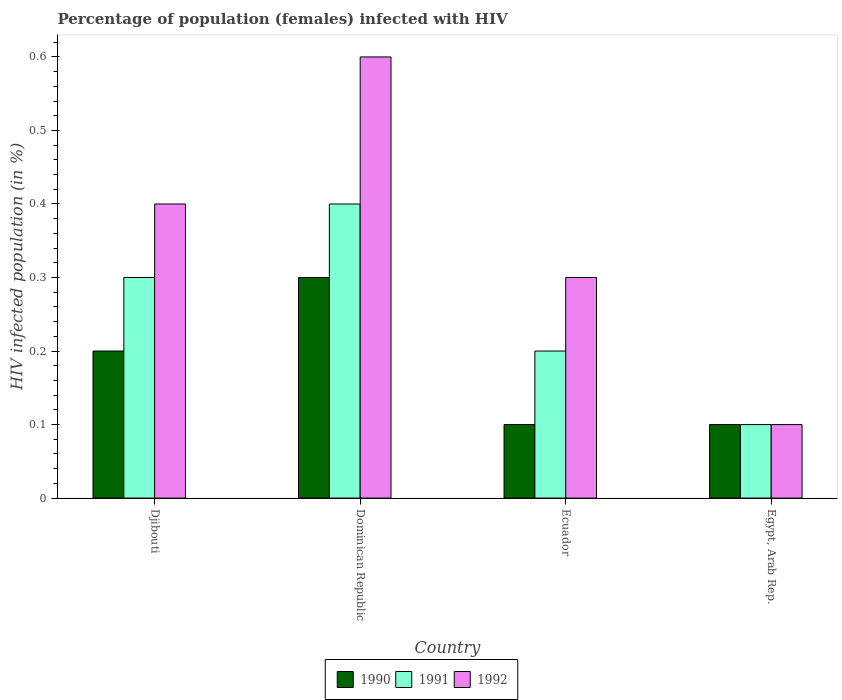How many groups of bars are there?
Offer a terse response. 4. Are the number of bars on each tick of the X-axis equal?
Keep it short and to the point. Yes. How many bars are there on the 4th tick from the left?
Ensure brevity in your answer.  3. How many bars are there on the 3rd tick from the right?
Provide a short and direct response. 3. What is the label of the 3rd group of bars from the left?
Provide a short and direct response. Ecuador. In how many cases, is the number of bars for a given country not equal to the number of legend labels?
Your answer should be very brief. 0. Across all countries, what is the maximum percentage of HIV infected female population in 1992?
Keep it short and to the point. 0.6. Across all countries, what is the minimum percentage of HIV infected female population in 1992?
Keep it short and to the point. 0.1. In which country was the percentage of HIV infected female population in 1992 maximum?
Provide a succinct answer. Dominican Republic. In which country was the percentage of HIV infected female population in 1990 minimum?
Keep it short and to the point. Ecuador. What is the total percentage of HIV infected female population in 1990 in the graph?
Keep it short and to the point. 0.7. What is the difference between the percentage of HIV infected female population in 1991 in Dominican Republic and that in Egypt, Arab Rep.?
Your answer should be compact. 0.3. What is the difference between the percentage of HIV infected female population in 1991 in Dominican Republic and the percentage of HIV infected female population in 1992 in Egypt, Arab Rep.?
Your response must be concise. 0.3. What is the average percentage of HIV infected female population in 1992 per country?
Provide a short and direct response. 0.35. In how many countries, is the percentage of HIV infected female population in 1992 greater than 0.26 %?
Offer a very short reply. 3. What is the ratio of the percentage of HIV infected female population in 1992 in Dominican Republic to that in Egypt, Arab Rep.?
Offer a very short reply. 6. What is the difference between the highest and the second highest percentage of HIV infected female population in 1991?
Provide a succinct answer. 0.2. What is the difference between the highest and the lowest percentage of HIV infected female population in 1990?
Provide a short and direct response. 0.2. In how many countries, is the percentage of HIV infected female population in 1991 greater than the average percentage of HIV infected female population in 1991 taken over all countries?
Make the answer very short. 2. Is the sum of the percentage of HIV infected female population in 1992 in Djibouti and Ecuador greater than the maximum percentage of HIV infected female population in 1990 across all countries?
Your answer should be very brief. Yes. Is it the case that in every country, the sum of the percentage of HIV infected female population in 1991 and percentage of HIV infected female population in 1990 is greater than the percentage of HIV infected female population in 1992?
Offer a terse response. Yes. How many bars are there?
Your response must be concise. 12. Are all the bars in the graph horizontal?
Make the answer very short. No. Are the values on the major ticks of Y-axis written in scientific E-notation?
Your answer should be compact. No. Where does the legend appear in the graph?
Provide a succinct answer. Bottom center. How many legend labels are there?
Provide a short and direct response. 3. What is the title of the graph?
Ensure brevity in your answer.  Percentage of population (females) infected with HIV. What is the label or title of the Y-axis?
Ensure brevity in your answer.  HIV infected population (in %). What is the HIV infected population (in %) in 1990 in Djibouti?
Your response must be concise. 0.2. What is the HIV infected population (in %) in 1991 in Djibouti?
Offer a very short reply. 0.3. What is the HIV infected population (in %) of 1992 in Djibouti?
Offer a very short reply. 0.4. What is the HIV infected population (in %) of 1991 in Ecuador?
Provide a short and direct response. 0.2. What is the HIV infected population (in %) of 1992 in Ecuador?
Provide a succinct answer. 0.3. What is the HIV infected population (in %) in 1990 in Egypt, Arab Rep.?
Provide a succinct answer. 0.1. What is the HIV infected population (in %) in 1991 in Egypt, Arab Rep.?
Offer a terse response. 0.1. What is the HIV infected population (in %) in 1992 in Egypt, Arab Rep.?
Your answer should be very brief. 0.1. Across all countries, what is the maximum HIV infected population (in %) in 1990?
Provide a succinct answer. 0.3. Across all countries, what is the maximum HIV infected population (in %) of 1991?
Your answer should be very brief. 0.4. Across all countries, what is the minimum HIV infected population (in %) in 1990?
Offer a very short reply. 0.1. What is the total HIV infected population (in %) in 1990 in the graph?
Provide a short and direct response. 0.7. What is the total HIV infected population (in %) in 1991 in the graph?
Keep it short and to the point. 1. What is the total HIV infected population (in %) of 1992 in the graph?
Ensure brevity in your answer.  1.4. What is the difference between the HIV infected population (in %) in 1991 in Djibouti and that in Dominican Republic?
Your answer should be very brief. -0.1. What is the difference between the HIV infected population (in %) in 1992 in Djibouti and that in Dominican Republic?
Provide a succinct answer. -0.2. What is the difference between the HIV infected population (in %) in 1992 in Djibouti and that in Ecuador?
Your answer should be very brief. 0.1. What is the difference between the HIV infected population (in %) of 1992 in Djibouti and that in Egypt, Arab Rep.?
Ensure brevity in your answer.  0.3. What is the difference between the HIV infected population (in %) of 1990 in Dominican Republic and that in Ecuador?
Give a very brief answer. 0.2. What is the difference between the HIV infected population (in %) in 1992 in Dominican Republic and that in Ecuador?
Make the answer very short. 0.3. What is the difference between the HIV infected population (in %) in 1991 in Dominican Republic and that in Egypt, Arab Rep.?
Offer a very short reply. 0.3. What is the difference between the HIV infected population (in %) of 1991 in Ecuador and that in Egypt, Arab Rep.?
Provide a succinct answer. 0.1. What is the difference between the HIV infected population (in %) of 1990 in Djibouti and the HIV infected population (in %) of 1991 in Dominican Republic?
Provide a succinct answer. -0.2. What is the difference between the HIV infected population (in %) in 1990 in Djibouti and the HIV infected population (in %) in 1992 in Dominican Republic?
Offer a very short reply. -0.4. What is the difference between the HIV infected population (in %) of 1990 in Djibouti and the HIV infected population (in %) of 1991 in Ecuador?
Your response must be concise. 0. What is the difference between the HIV infected population (in %) in 1990 in Djibouti and the HIV infected population (in %) in 1992 in Ecuador?
Offer a very short reply. -0.1. What is the difference between the HIV infected population (in %) of 1991 in Djibouti and the HIV infected population (in %) of 1992 in Ecuador?
Your response must be concise. 0. What is the difference between the HIV infected population (in %) in 1990 in Dominican Republic and the HIV infected population (in %) in 1991 in Ecuador?
Provide a short and direct response. 0.1. What is the difference between the HIV infected population (in %) in 1990 in Ecuador and the HIV infected population (in %) in 1991 in Egypt, Arab Rep.?
Provide a succinct answer. 0. What is the average HIV infected population (in %) in 1990 per country?
Provide a succinct answer. 0.17. What is the average HIV infected population (in %) in 1992 per country?
Your answer should be very brief. 0.35. What is the difference between the HIV infected population (in %) in 1991 and HIV infected population (in %) in 1992 in Djibouti?
Your answer should be compact. -0.1. What is the difference between the HIV infected population (in %) in 1990 and HIV infected population (in %) in 1991 in Dominican Republic?
Provide a succinct answer. -0.1. What is the difference between the HIV infected population (in %) in 1990 and HIV infected population (in %) in 1992 in Dominican Republic?
Make the answer very short. -0.3. What is the difference between the HIV infected population (in %) in 1991 and HIV infected population (in %) in 1992 in Dominican Republic?
Give a very brief answer. -0.2. What is the difference between the HIV infected population (in %) of 1990 and HIV infected population (in %) of 1991 in Ecuador?
Your answer should be compact. -0.1. What is the difference between the HIV infected population (in %) in 1991 and HIV infected population (in %) in 1992 in Ecuador?
Offer a terse response. -0.1. What is the difference between the HIV infected population (in %) of 1990 and HIV infected population (in %) of 1991 in Egypt, Arab Rep.?
Your answer should be very brief. 0. What is the difference between the HIV infected population (in %) in 1991 and HIV infected population (in %) in 1992 in Egypt, Arab Rep.?
Keep it short and to the point. 0. What is the ratio of the HIV infected population (in %) of 1990 in Djibouti to that in Dominican Republic?
Provide a succinct answer. 0.67. What is the ratio of the HIV infected population (in %) in 1990 in Djibouti to that in Ecuador?
Your response must be concise. 2. What is the ratio of the HIV infected population (in %) in 1991 in Djibouti to that in Ecuador?
Provide a short and direct response. 1.5. What is the ratio of the HIV infected population (in %) of 1990 in Djibouti to that in Egypt, Arab Rep.?
Provide a succinct answer. 2. What is the ratio of the HIV infected population (in %) in 1990 in Dominican Republic to that in Ecuador?
Ensure brevity in your answer.  3. What is the ratio of the HIV infected population (in %) of 1991 in Dominican Republic to that in Ecuador?
Give a very brief answer. 2. What is the ratio of the HIV infected population (in %) of 1991 in Dominican Republic to that in Egypt, Arab Rep.?
Make the answer very short. 4. What is the ratio of the HIV infected population (in %) in 1990 in Ecuador to that in Egypt, Arab Rep.?
Keep it short and to the point. 1. What is the ratio of the HIV infected population (in %) of 1991 in Ecuador to that in Egypt, Arab Rep.?
Make the answer very short. 2. What is the ratio of the HIV infected population (in %) in 1992 in Ecuador to that in Egypt, Arab Rep.?
Offer a very short reply. 3. What is the difference between the highest and the lowest HIV infected population (in %) of 1992?
Ensure brevity in your answer.  0.5. 